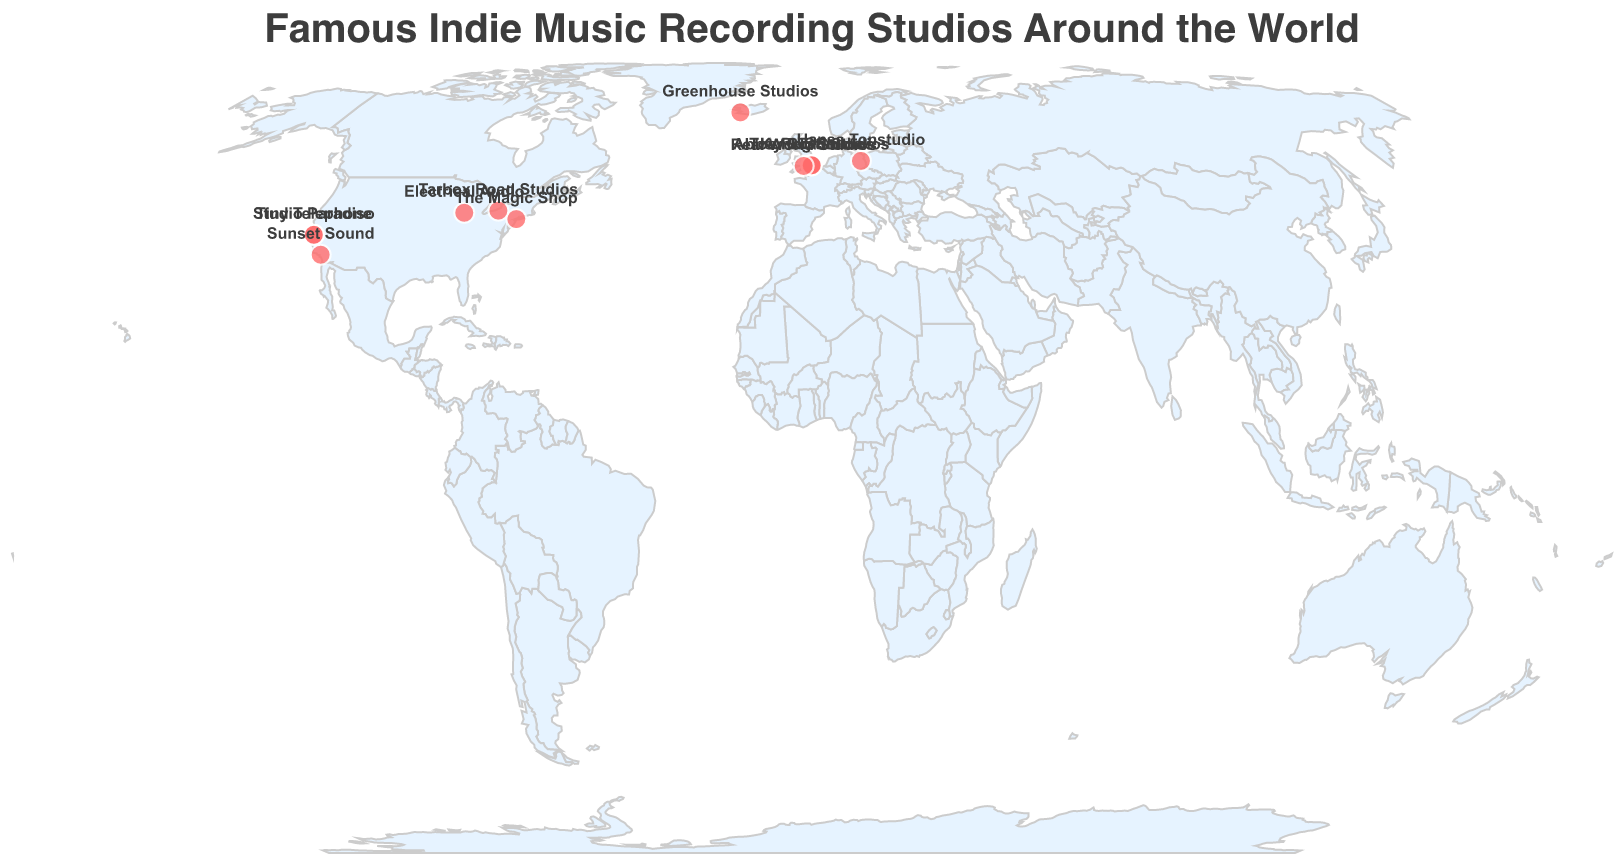What is the title of the figure? The title is typically located at the top of the figure and clearly indicates what the chart is about. In this case, the title is "Famous Indie Music Recording Studios Around the World."
Answer: Famous Indie Music Recording Studios Around the World Which studio is located the farthest north? To determine this, we need to find the studio with the highest latitude. From the data, Greenhouse Studios in Reykjavik, Iceland, has the highest latitude at 64.1355.
Answer: Greenhouse Studios How many studios are located in the USA? By counting the studios listed in the USA, we find that there are five: Electrical Audio, Sunset Sound, Tiny Telephone, The Magic Shop, and Tarbox Road Studios.
Answer: 5 Which city has the most recording studios listed? By examining the figure, we identify which city appears most frequently. London has three studios: Abbey Road Studios, Konk Studios, and Toe Rag Studios.
Answer: London What notable artist recorded at Real World Studios? By looking at the tooltip information for Real World Studios, we see that the notable artist is Peter Gabriel.
Answer: Peter Gabriel Compare the location of Abbey Road Studios and Toe Rag Studios. Which one is farther south? To determine this, we compare the latitudes of both studios. Abbey Road Studios is at 51.5320, and Toe Rag Studios is at 51.5499. The smaller latitude value indicates a location farther south, so Abbey Road Studios is farther south.
Answer: Abbey Road Studios Which studio is closest to the prime meridian? To find the closest studio to the prime meridian (0° longitude), we check the absolute value of the longitudes. Abbey Road Studios in London, with a longitude of -0.1784, is the closest.
Answer: Abbey Road Studios How many countries have at least one famous indie music recording studio listed? From the data, we can identify the unique countries: United Kingdom, USA, Iceland, and Germany, totaling four countries.
Answer: 4 Which notable artist recorded at a studio in Berlin? By identifying the studio located in Berlin on the figure, we observe that Hansa Tonstudio's notable artist is David Bowie.
Answer: David Bowie What is the easternmost studio on the map? By checking the studio with the highest longitude, we find that Hansa Tonstudio in Berlin, Germany, at 13.3750 longitude, is the easternmost.
Answer: Hansa Tonstudio 